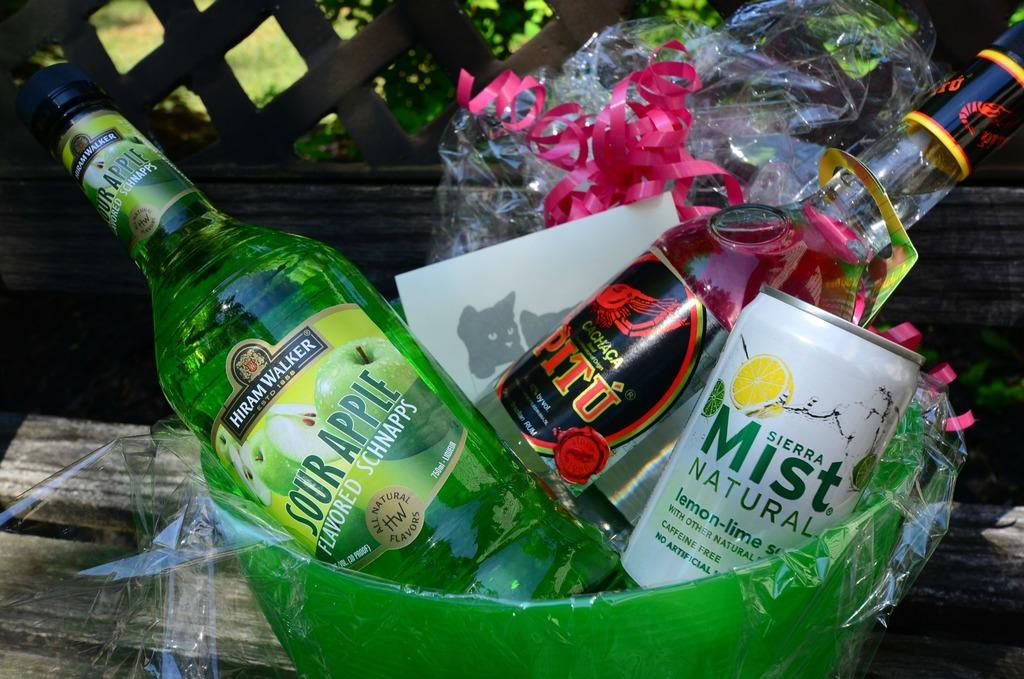<image>
Give a short and clear explanation of the subsequent image. a drink basket with Sierra Mist Natural and Sour apple Flavored Schnapps 